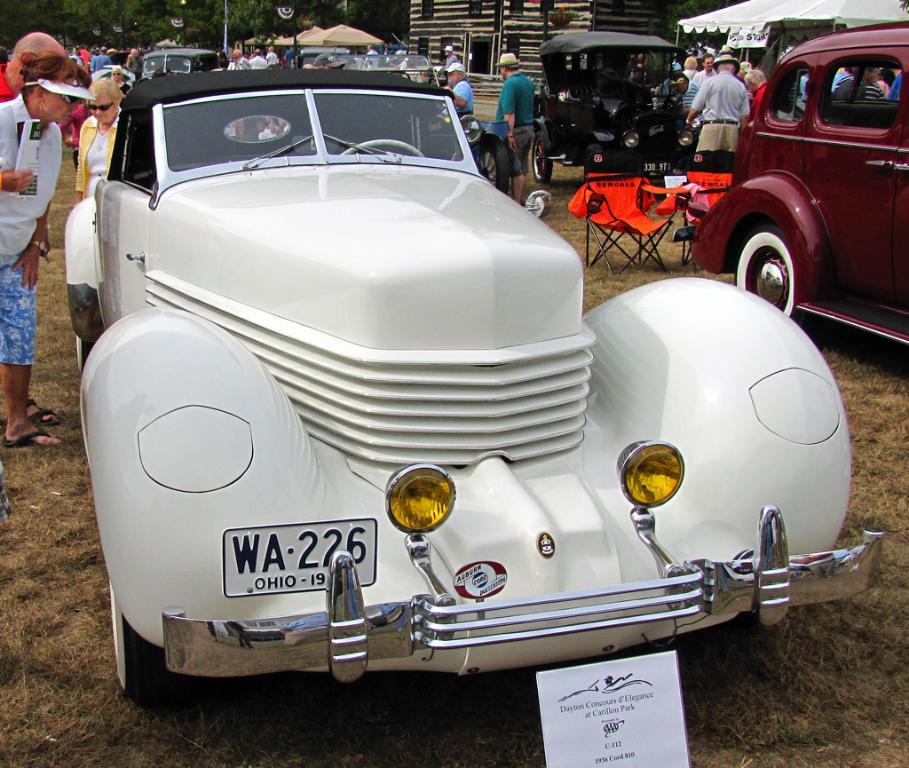What types of objects are on the ground in the image? There are vehicles on the ground in the image. Can you describe the people in the image? Yes, there are people in the image. What type of furniture is present in the image? Chairs are present in the image. What other structures can be seen in the image? Boards and a pole are visible in the image. What type of temporary shelter is present in the image? Tents are present in the image. What type of permanent structure is present in the image? There is a house in the image. What type of natural elements are visible in the image? Trees are visible in the image. Where is the kettle located in the image? There is no kettle present in the image. What fact needs to be corrected in the image? The image does not contain any incorrect facts; it accurately depicts the objects and structures mentioned in the provided facts. 